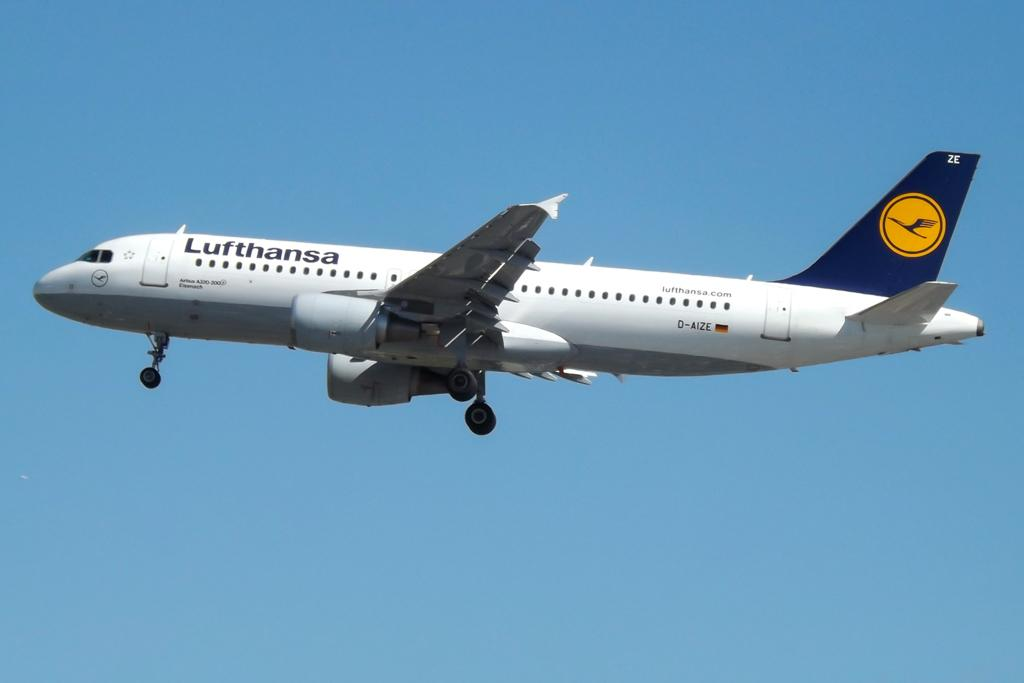<image>
Offer a succinct explanation of the picture presented. A Lufthansa airplane flying in the blue sky 